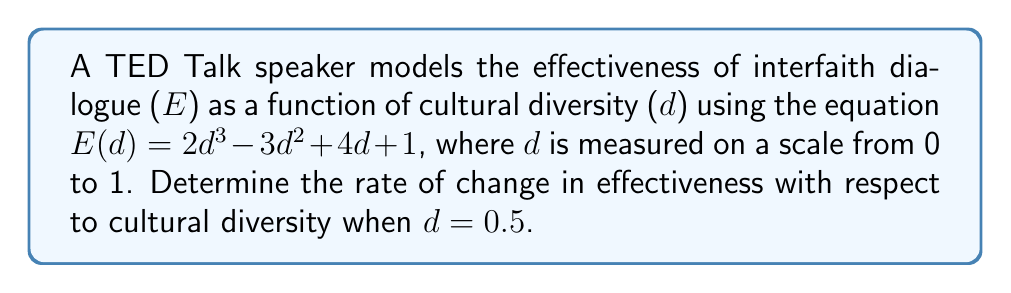Could you help me with this problem? To find the rate of change in effectiveness with respect to cultural diversity, we need to calculate the derivative of E(d) and evaluate it at d = 0.5.

Step 1: Calculate the derivative of E(d)
$$\frac{dE}{dd} = \frac{d}{dd}(2d^3 - 3d^2 + 4d + 1)$$
$$\frac{dE}{dd} = 6d^2 - 6d + 4$$

Step 2: Evaluate the derivative at d = 0.5
$$\frac{dE}{dd}\bigg|_{d=0.5} = 6(0.5)^2 - 6(0.5) + 4$$
$$= 6(0.25) - 3 + 4$$
$$= 1.5 - 3 + 4$$
$$= 2.5$$

The rate of change in effectiveness with respect to cultural diversity when d = 0.5 is 2.5.
Answer: 2.5 